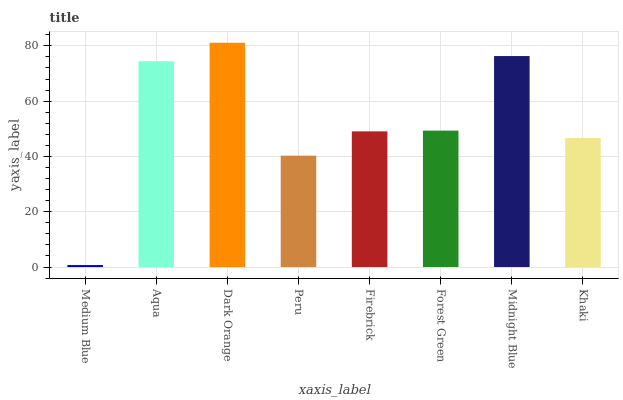Is Medium Blue the minimum?
Answer yes or no. Yes. Is Dark Orange the maximum?
Answer yes or no. Yes. Is Aqua the minimum?
Answer yes or no. No. Is Aqua the maximum?
Answer yes or no. No. Is Aqua greater than Medium Blue?
Answer yes or no. Yes. Is Medium Blue less than Aqua?
Answer yes or no. Yes. Is Medium Blue greater than Aqua?
Answer yes or no. No. Is Aqua less than Medium Blue?
Answer yes or no. No. Is Forest Green the high median?
Answer yes or no. Yes. Is Firebrick the low median?
Answer yes or no. Yes. Is Peru the high median?
Answer yes or no. No. Is Forest Green the low median?
Answer yes or no. No. 